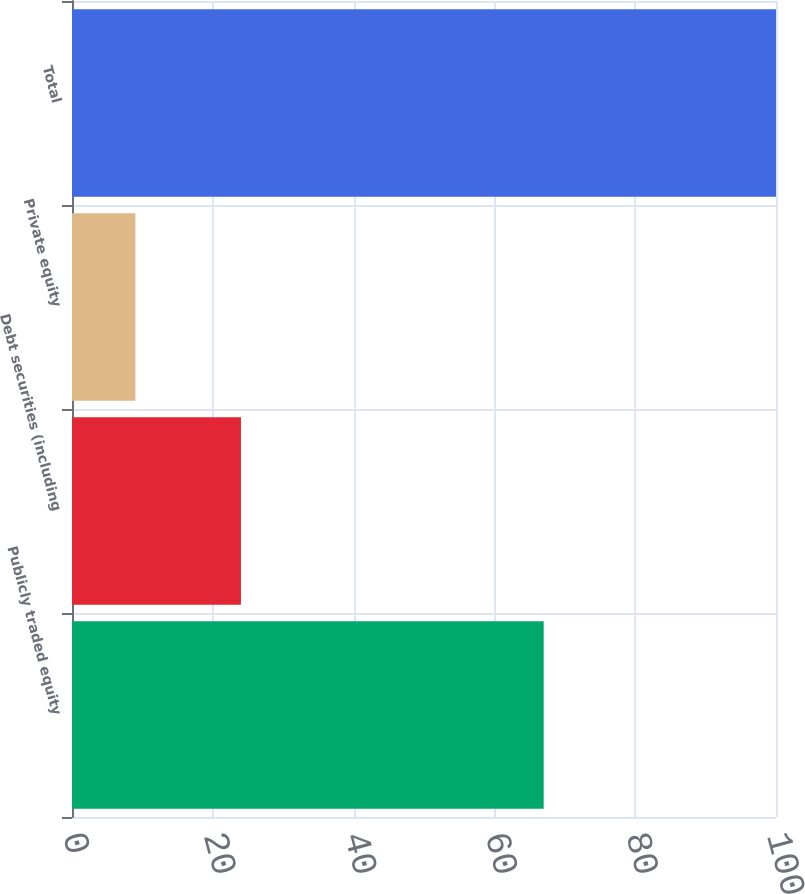Convert chart to OTSL. <chart><loc_0><loc_0><loc_500><loc_500><bar_chart><fcel>Publicly traded equity<fcel>Debt securities (including<fcel>Private equity<fcel>Total<nl><fcel>67<fcel>24<fcel>9<fcel>100<nl></chart> 